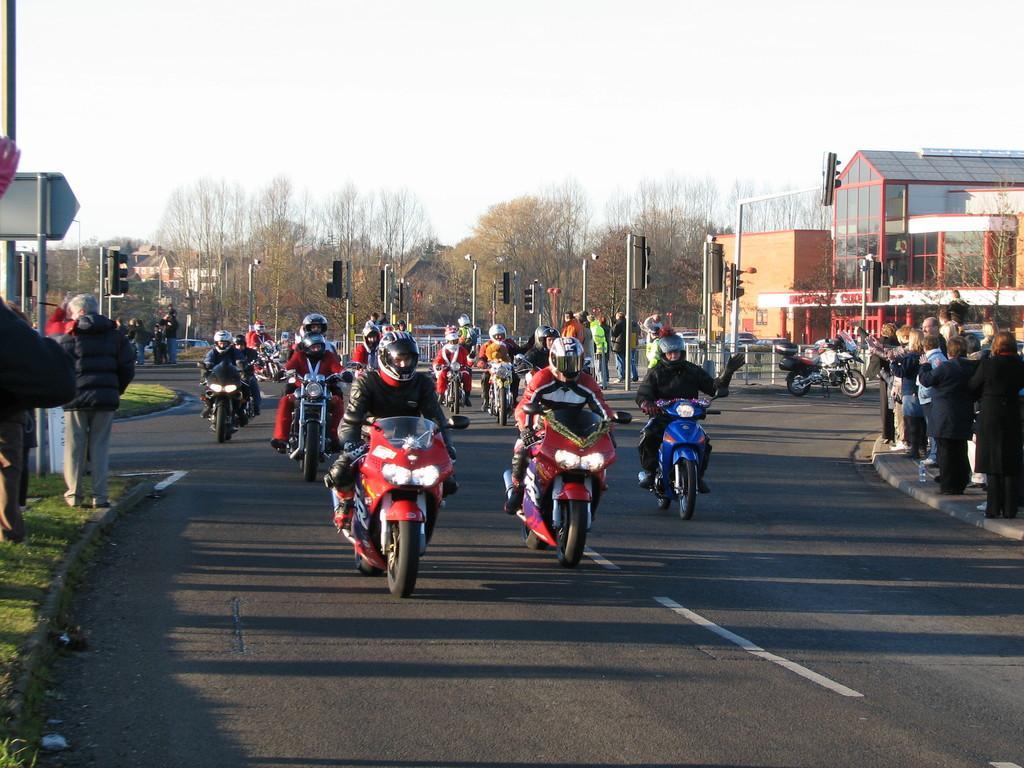How would you summarize this image in a sentence or two? In this image we can see there are persons riding a motorcycle on the road and few persons standing on the ground. And at the back there are street lights, board, grass, trees, buildings and the sky. 